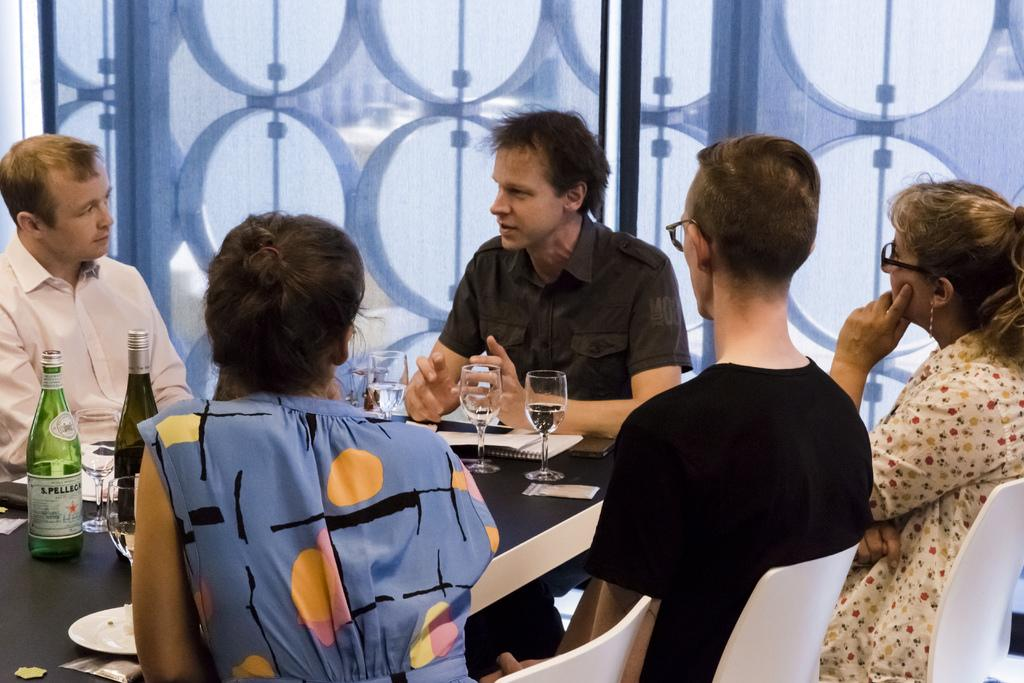What are the people in the image doing? There is a group of people sitting on chairs in the image. What can be seen on the tables in the image? There are wine bottles and glasses on the tables. Are there any other objects on the tables? Yes, there are other objects on the tables. What type of bells can be heard ringing in the image? There are no bells present in the image, and therefore no sound can be heard. 